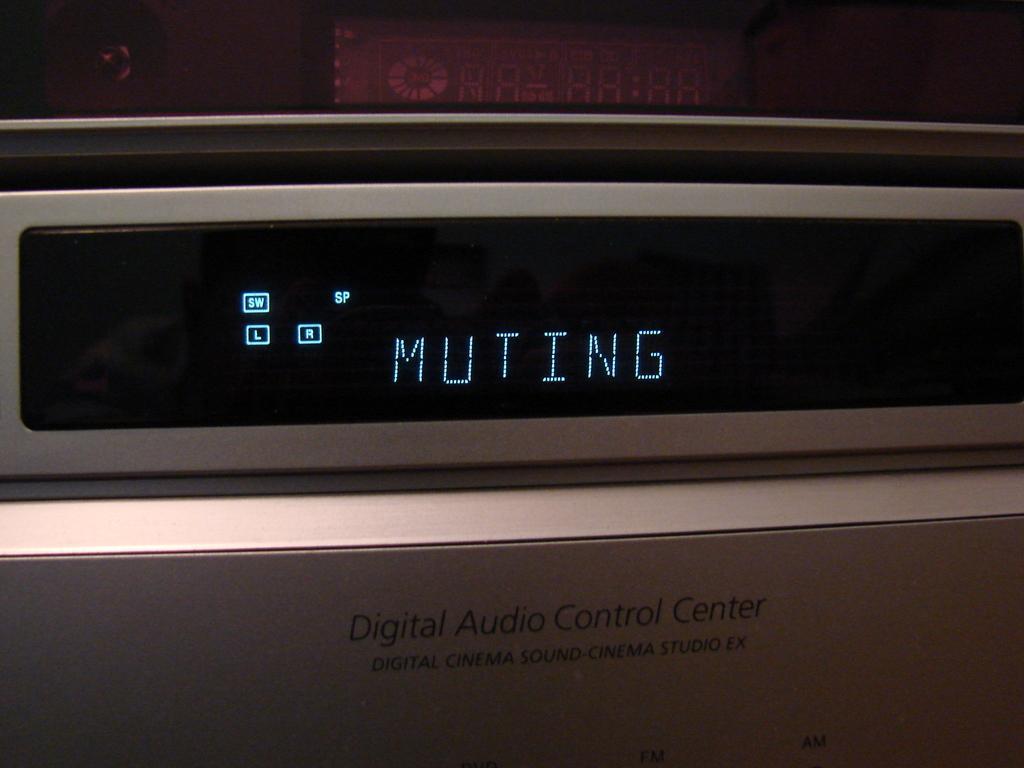Describe this image in one or two sentences. In the middle of the picture, we see a display device. It is displaying something. At the bottom of the picture, we see a white color thing on which "Digital Audio Control Center" is written. In the background, it is in brown and black color. This picture might be clicked in the dark. 